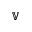<formula> <loc_0><loc_0><loc_500><loc_500>\mathbb { V }</formula> 